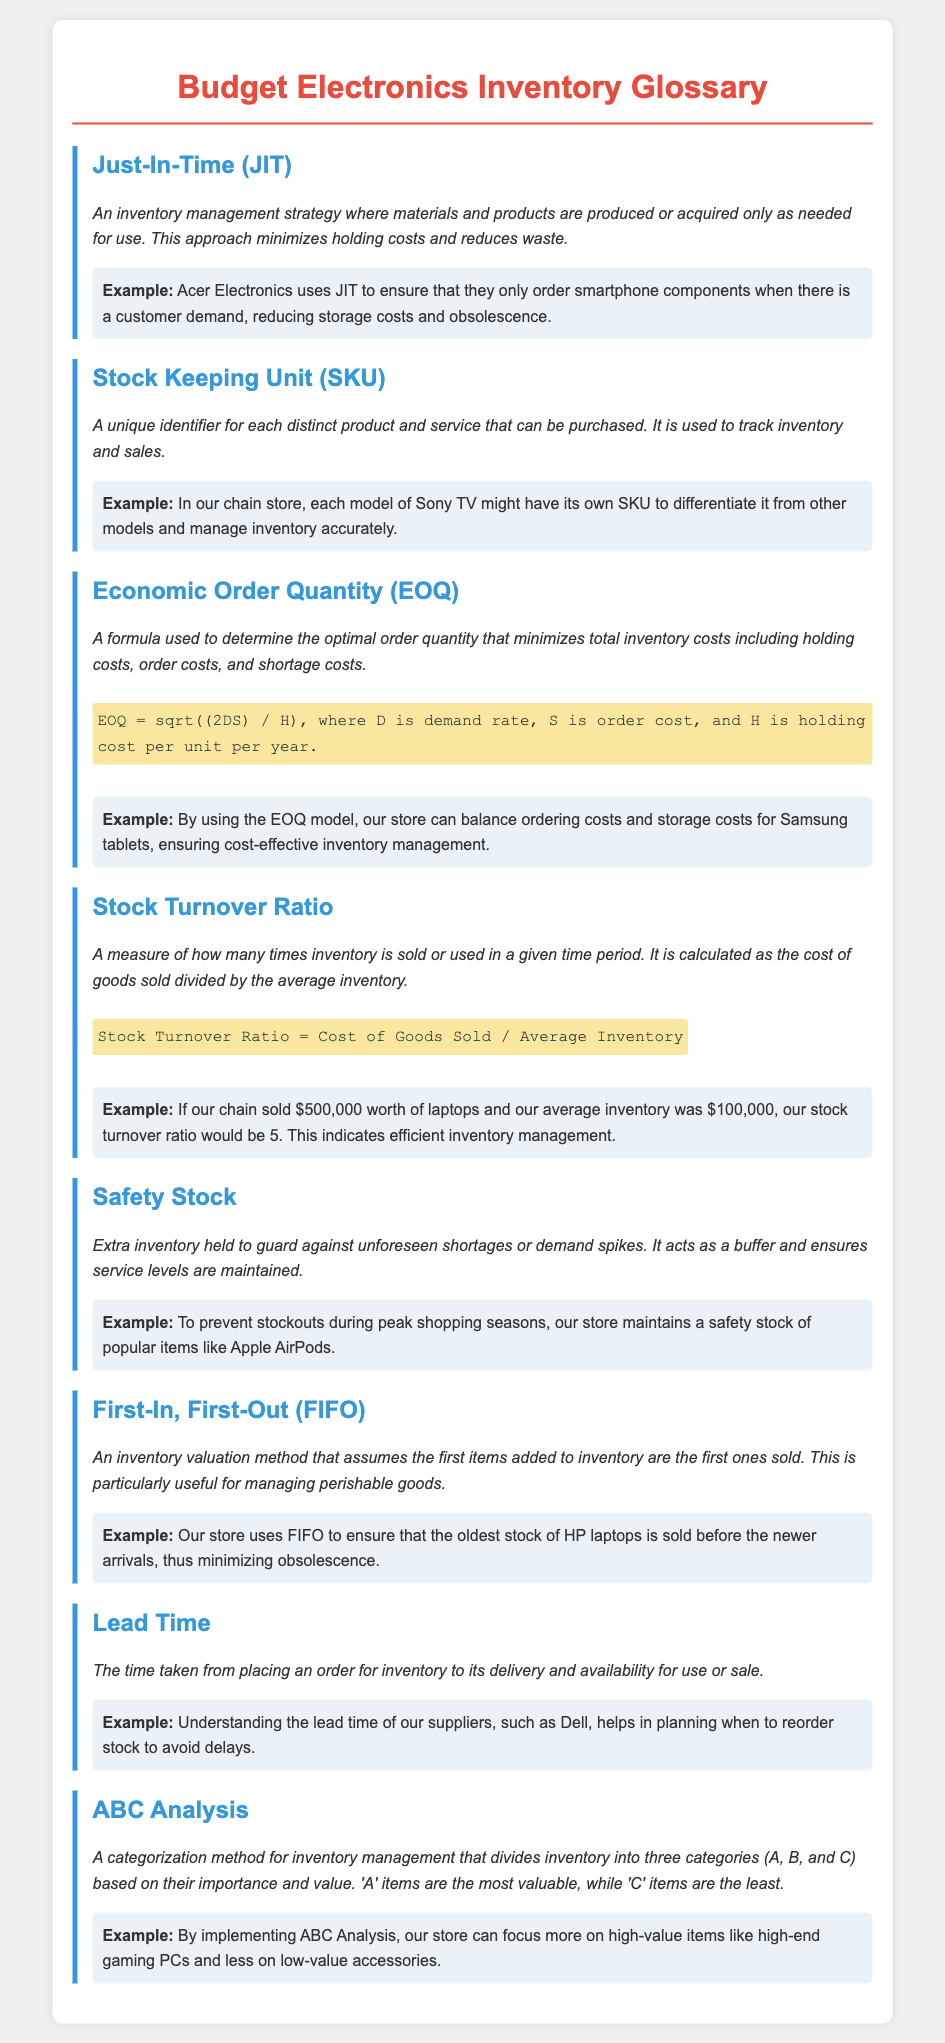What is Just-In-Time (JIT)? JIT is an inventory management strategy to minimize holding costs and reduce waste by producing or acquiring materials only as needed.
Answer: An inventory management strategy What does SKU stand for? SKU stands for Stock Keeping Unit, which is a unique identifier for each distinct product and service.
Answer: Stock Keeping Unit What is the formula for Economic Order Quantity (EOQ)? The formula for EOQ is used to determine the optimal order quantity that minimizes total inventory costs, expressed as EOQ = sqrt((2DS) / H).
Answer: EOQ = sqrt((2DS) / H) What is considered a high Stock Turnover Ratio? A high stock turnover ratio indicates efficient inventory management, and in this context, a ratio of 5 is explicitly noted.
Answer: 5 What is Safety Stock? Safety stock is extra inventory held to guard against unforeseen shortages or demand spikes.
Answer: Extra inventory What method does the store use to manage perishable goods? The store uses the First-In, First-Out (FIFO) method to ensure the oldest stock is sold first.
Answer: First-In, First-Out (FIFO) What does ABC Analysis categorize? ABC Analysis categorizes inventory into three categories (A, B, and C) based on their importance and value.
Answer: Inventory into three categories What should be considered when understanding Lead Time? Understanding lead time helps in planning when to reorder stock to avoid delays.
Answer: Time taken for inventory delivery What examples are given for items in Safety Stock? Popular items like Apple AirPods are maintained as safety stock to prevent stockouts.
Answer: Apple AirPods What type of items are categorized as 'A' items in ABC Analysis? 'A' items are the most valuable in the classification of inventory.
Answer: Most valuable 